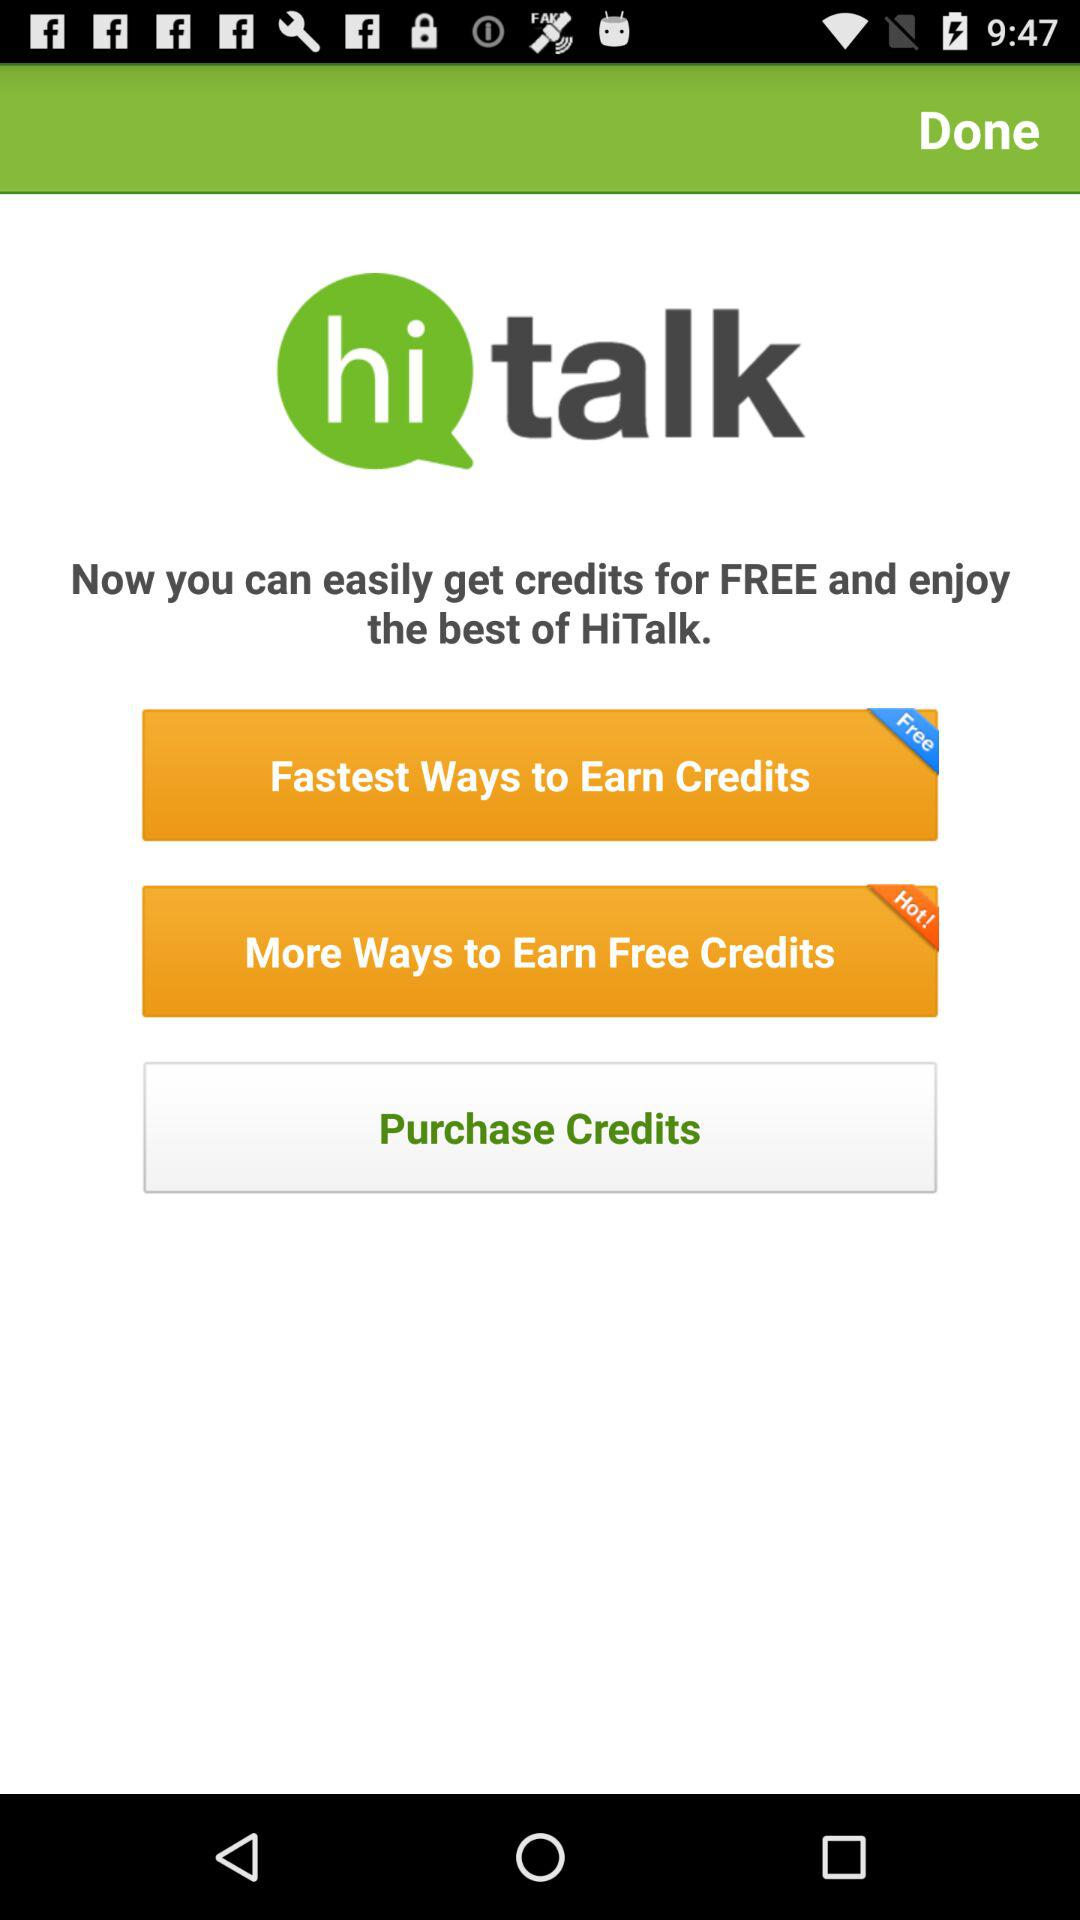What is the name of the application? The name of the application is "hi talk". 